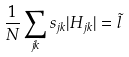Convert formula to latex. <formula><loc_0><loc_0><loc_500><loc_500>\frac { 1 } { N } \sum _ { j k } s _ { j k } | H _ { j k } | = \tilde { l }</formula> 